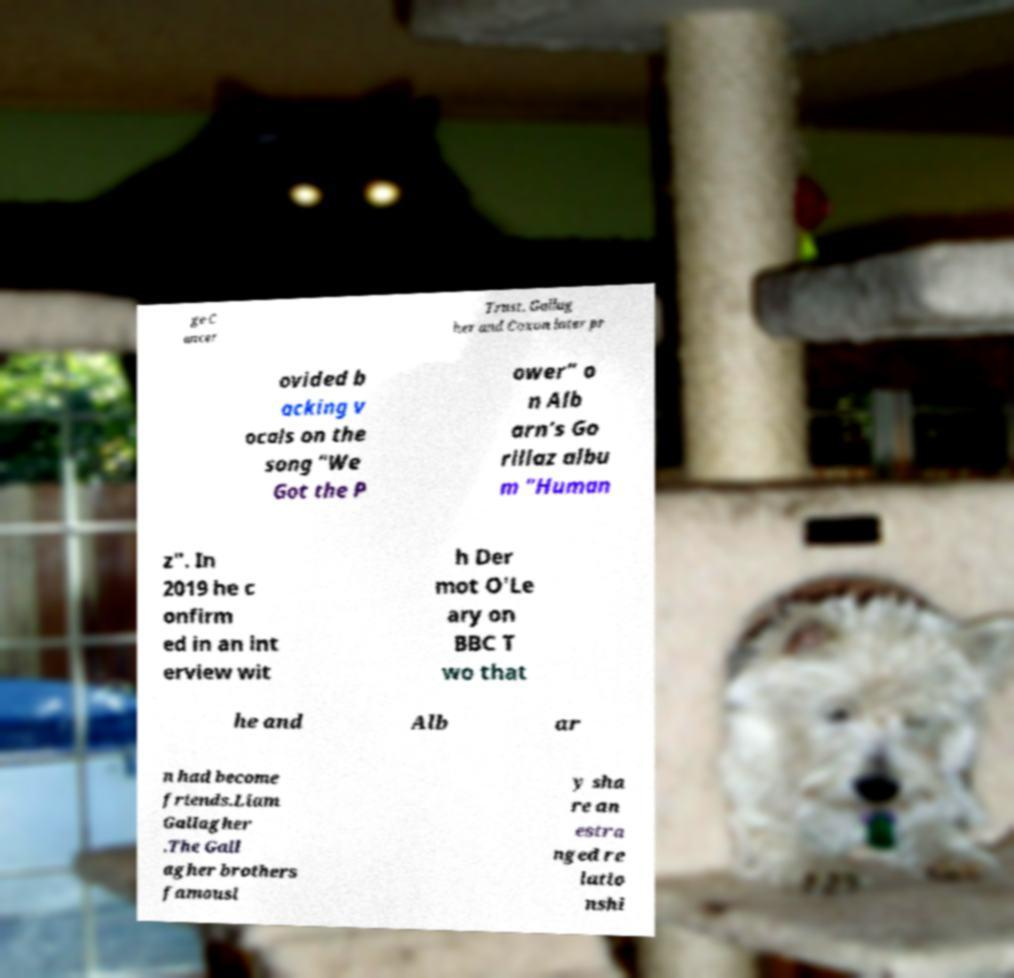I need the written content from this picture converted into text. Can you do that? ge C ancer Trust. Gallag her and Coxon later pr ovided b acking v ocals on the song "We Got the P ower" o n Alb arn's Go rillaz albu m "Human z". In 2019 he c onfirm ed in an int erview wit h Der mot O'Le ary on BBC T wo that he and Alb ar n had become friends.Liam Gallagher .The Gall agher brothers famousl y sha re an estra nged re latio nshi 